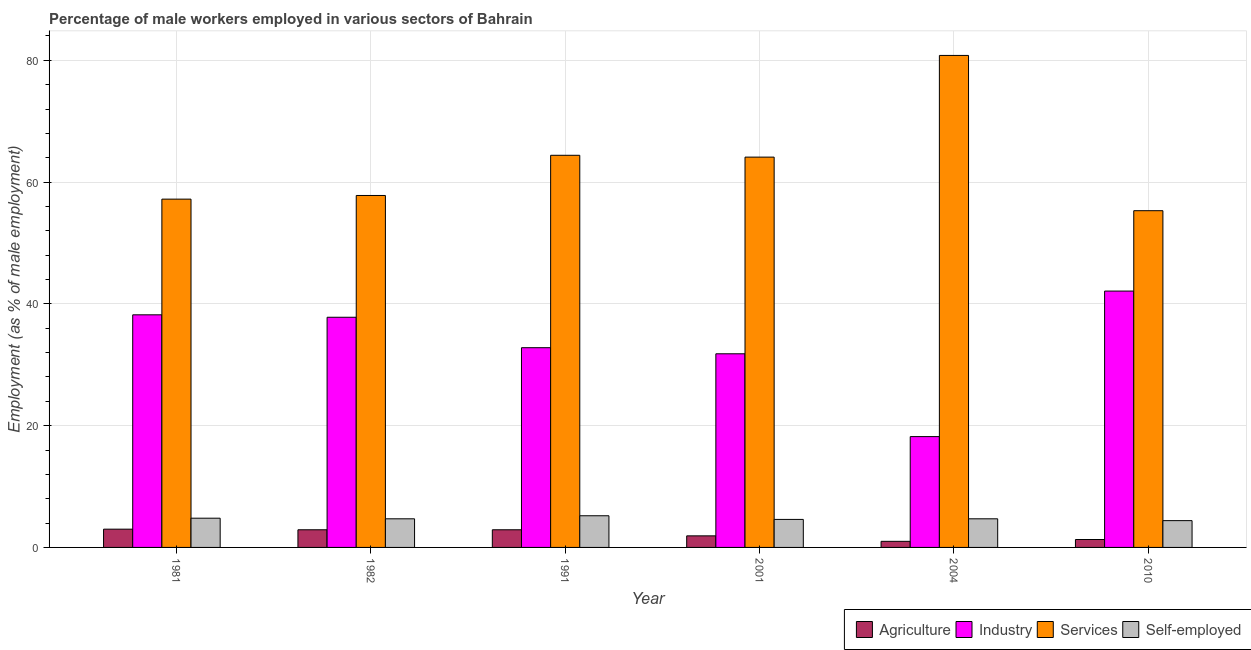How many different coloured bars are there?
Keep it short and to the point. 4. How many groups of bars are there?
Keep it short and to the point. 6. Are the number of bars on each tick of the X-axis equal?
Ensure brevity in your answer.  Yes. What is the percentage of male workers in industry in 1982?
Your answer should be very brief. 37.8. Across all years, what is the maximum percentage of male workers in industry?
Ensure brevity in your answer.  42.1. Across all years, what is the minimum percentage of male workers in services?
Your answer should be compact. 55.3. What is the total percentage of male workers in agriculture in the graph?
Your response must be concise. 13. What is the difference between the percentage of self employed male workers in 1981 and that in 2001?
Provide a succinct answer. 0.2. What is the difference between the percentage of male workers in industry in 1991 and the percentage of male workers in agriculture in 1982?
Your response must be concise. -5. What is the average percentage of male workers in agriculture per year?
Ensure brevity in your answer.  2.17. In the year 1991, what is the difference between the percentage of self employed male workers and percentage of male workers in agriculture?
Make the answer very short. 0. What is the ratio of the percentage of self employed male workers in 1991 to that in 2004?
Provide a succinct answer. 1.11. Is the percentage of male workers in services in 1981 less than that in 2001?
Provide a succinct answer. Yes. Is the difference between the percentage of male workers in agriculture in 1982 and 2001 greater than the difference between the percentage of self employed male workers in 1982 and 2001?
Your response must be concise. No. What is the difference between the highest and the second highest percentage of male workers in services?
Your answer should be compact. 16.4. What is the difference between the highest and the lowest percentage of self employed male workers?
Give a very brief answer. 0.8. In how many years, is the percentage of self employed male workers greater than the average percentage of self employed male workers taken over all years?
Keep it short and to the point. 2. Is the sum of the percentage of male workers in industry in 2004 and 2010 greater than the maximum percentage of male workers in services across all years?
Make the answer very short. Yes. Is it the case that in every year, the sum of the percentage of male workers in services and percentage of male workers in agriculture is greater than the sum of percentage of male workers in industry and percentage of self employed male workers?
Ensure brevity in your answer.  Yes. What does the 2nd bar from the left in 1981 represents?
Offer a very short reply. Industry. What does the 1st bar from the right in 2010 represents?
Provide a succinct answer. Self-employed. How many bars are there?
Make the answer very short. 24. Are all the bars in the graph horizontal?
Provide a succinct answer. No. How many years are there in the graph?
Offer a very short reply. 6. Does the graph contain any zero values?
Make the answer very short. No. Does the graph contain grids?
Provide a succinct answer. Yes. Where does the legend appear in the graph?
Your response must be concise. Bottom right. What is the title of the graph?
Your response must be concise. Percentage of male workers employed in various sectors of Bahrain. Does "Primary" appear as one of the legend labels in the graph?
Keep it short and to the point. No. What is the label or title of the Y-axis?
Give a very brief answer. Employment (as % of male employment). What is the Employment (as % of male employment) in Agriculture in 1981?
Your response must be concise. 3. What is the Employment (as % of male employment) in Industry in 1981?
Offer a terse response. 38.2. What is the Employment (as % of male employment) of Services in 1981?
Your answer should be very brief. 57.2. What is the Employment (as % of male employment) in Self-employed in 1981?
Provide a succinct answer. 4.8. What is the Employment (as % of male employment) of Agriculture in 1982?
Offer a terse response. 2.9. What is the Employment (as % of male employment) in Industry in 1982?
Provide a succinct answer. 37.8. What is the Employment (as % of male employment) in Services in 1982?
Ensure brevity in your answer.  57.8. What is the Employment (as % of male employment) of Self-employed in 1982?
Your answer should be compact. 4.7. What is the Employment (as % of male employment) of Agriculture in 1991?
Offer a terse response. 2.9. What is the Employment (as % of male employment) of Industry in 1991?
Ensure brevity in your answer.  32.8. What is the Employment (as % of male employment) in Services in 1991?
Your answer should be very brief. 64.4. What is the Employment (as % of male employment) of Self-employed in 1991?
Your answer should be very brief. 5.2. What is the Employment (as % of male employment) in Agriculture in 2001?
Offer a very short reply. 1.9. What is the Employment (as % of male employment) of Industry in 2001?
Keep it short and to the point. 31.8. What is the Employment (as % of male employment) of Services in 2001?
Your response must be concise. 64.1. What is the Employment (as % of male employment) of Self-employed in 2001?
Provide a succinct answer. 4.6. What is the Employment (as % of male employment) of Agriculture in 2004?
Give a very brief answer. 1. What is the Employment (as % of male employment) of Industry in 2004?
Offer a terse response. 18.2. What is the Employment (as % of male employment) of Services in 2004?
Offer a terse response. 80.8. What is the Employment (as % of male employment) in Self-employed in 2004?
Provide a succinct answer. 4.7. What is the Employment (as % of male employment) of Agriculture in 2010?
Make the answer very short. 1.3. What is the Employment (as % of male employment) of Industry in 2010?
Make the answer very short. 42.1. What is the Employment (as % of male employment) in Services in 2010?
Provide a short and direct response. 55.3. What is the Employment (as % of male employment) of Self-employed in 2010?
Your response must be concise. 4.4. Across all years, what is the maximum Employment (as % of male employment) of Agriculture?
Make the answer very short. 3. Across all years, what is the maximum Employment (as % of male employment) of Industry?
Keep it short and to the point. 42.1. Across all years, what is the maximum Employment (as % of male employment) of Services?
Offer a terse response. 80.8. Across all years, what is the maximum Employment (as % of male employment) in Self-employed?
Your answer should be compact. 5.2. Across all years, what is the minimum Employment (as % of male employment) of Industry?
Offer a terse response. 18.2. Across all years, what is the minimum Employment (as % of male employment) of Services?
Your answer should be very brief. 55.3. Across all years, what is the minimum Employment (as % of male employment) of Self-employed?
Your answer should be compact. 4.4. What is the total Employment (as % of male employment) in Agriculture in the graph?
Provide a short and direct response. 13. What is the total Employment (as % of male employment) of Industry in the graph?
Your answer should be very brief. 200.9. What is the total Employment (as % of male employment) of Services in the graph?
Make the answer very short. 379.6. What is the total Employment (as % of male employment) of Self-employed in the graph?
Provide a succinct answer. 28.4. What is the difference between the Employment (as % of male employment) of Agriculture in 1981 and that in 1982?
Your answer should be compact. 0.1. What is the difference between the Employment (as % of male employment) in Services in 1981 and that in 1982?
Your answer should be compact. -0.6. What is the difference between the Employment (as % of male employment) in Self-employed in 1981 and that in 1982?
Keep it short and to the point. 0.1. What is the difference between the Employment (as % of male employment) of Agriculture in 1981 and that in 2001?
Offer a terse response. 1.1. What is the difference between the Employment (as % of male employment) in Services in 1981 and that in 2001?
Your response must be concise. -6.9. What is the difference between the Employment (as % of male employment) in Self-employed in 1981 and that in 2001?
Keep it short and to the point. 0.2. What is the difference between the Employment (as % of male employment) of Agriculture in 1981 and that in 2004?
Your answer should be compact. 2. What is the difference between the Employment (as % of male employment) of Industry in 1981 and that in 2004?
Offer a very short reply. 20. What is the difference between the Employment (as % of male employment) in Services in 1981 and that in 2004?
Offer a terse response. -23.6. What is the difference between the Employment (as % of male employment) of Agriculture in 1981 and that in 2010?
Make the answer very short. 1.7. What is the difference between the Employment (as % of male employment) in Industry in 1982 and that in 1991?
Offer a very short reply. 5. What is the difference between the Employment (as % of male employment) in Self-employed in 1982 and that in 1991?
Provide a succinct answer. -0.5. What is the difference between the Employment (as % of male employment) of Agriculture in 1982 and that in 2001?
Your response must be concise. 1. What is the difference between the Employment (as % of male employment) of Industry in 1982 and that in 2001?
Make the answer very short. 6. What is the difference between the Employment (as % of male employment) of Services in 1982 and that in 2001?
Provide a short and direct response. -6.3. What is the difference between the Employment (as % of male employment) in Self-employed in 1982 and that in 2001?
Your response must be concise. 0.1. What is the difference between the Employment (as % of male employment) in Agriculture in 1982 and that in 2004?
Offer a terse response. 1.9. What is the difference between the Employment (as % of male employment) of Industry in 1982 and that in 2004?
Ensure brevity in your answer.  19.6. What is the difference between the Employment (as % of male employment) of Services in 1982 and that in 2004?
Your answer should be very brief. -23. What is the difference between the Employment (as % of male employment) of Self-employed in 1982 and that in 2004?
Ensure brevity in your answer.  0. What is the difference between the Employment (as % of male employment) of Industry in 1982 and that in 2010?
Give a very brief answer. -4.3. What is the difference between the Employment (as % of male employment) of Agriculture in 1991 and that in 2001?
Your response must be concise. 1. What is the difference between the Employment (as % of male employment) in Agriculture in 1991 and that in 2004?
Make the answer very short. 1.9. What is the difference between the Employment (as % of male employment) in Services in 1991 and that in 2004?
Ensure brevity in your answer.  -16.4. What is the difference between the Employment (as % of male employment) of Self-employed in 1991 and that in 2004?
Provide a succinct answer. 0.5. What is the difference between the Employment (as % of male employment) in Agriculture in 1991 and that in 2010?
Offer a terse response. 1.6. What is the difference between the Employment (as % of male employment) in Industry in 1991 and that in 2010?
Provide a succinct answer. -9.3. What is the difference between the Employment (as % of male employment) of Self-employed in 1991 and that in 2010?
Keep it short and to the point. 0.8. What is the difference between the Employment (as % of male employment) of Industry in 2001 and that in 2004?
Provide a short and direct response. 13.6. What is the difference between the Employment (as % of male employment) of Services in 2001 and that in 2004?
Provide a short and direct response. -16.7. What is the difference between the Employment (as % of male employment) of Agriculture in 2001 and that in 2010?
Make the answer very short. 0.6. What is the difference between the Employment (as % of male employment) of Industry in 2001 and that in 2010?
Your answer should be compact. -10.3. What is the difference between the Employment (as % of male employment) of Services in 2001 and that in 2010?
Give a very brief answer. 8.8. What is the difference between the Employment (as % of male employment) of Self-employed in 2001 and that in 2010?
Make the answer very short. 0.2. What is the difference between the Employment (as % of male employment) in Industry in 2004 and that in 2010?
Offer a very short reply. -23.9. What is the difference between the Employment (as % of male employment) in Self-employed in 2004 and that in 2010?
Offer a terse response. 0.3. What is the difference between the Employment (as % of male employment) of Agriculture in 1981 and the Employment (as % of male employment) of Industry in 1982?
Your answer should be compact. -34.8. What is the difference between the Employment (as % of male employment) in Agriculture in 1981 and the Employment (as % of male employment) in Services in 1982?
Ensure brevity in your answer.  -54.8. What is the difference between the Employment (as % of male employment) of Industry in 1981 and the Employment (as % of male employment) of Services in 1982?
Keep it short and to the point. -19.6. What is the difference between the Employment (as % of male employment) in Industry in 1981 and the Employment (as % of male employment) in Self-employed in 1982?
Your response must be concise. 33.5. What is the difference between the Employment (as % of male employment) in Services in 1981 and the Employment (as % of male employment) in Self-employed in 1982?
Offer a very short reply. 52.5. What is the difference between the Employment (as % of male employment) in Agriculture in 1981 and the Employment (as % of male employment) in Industry in 1991?
Provide a succinct answer. -29.8. What is the difference between the Employment (as % of male employment) in Agriculture in 1981 and the Employment (as % of male employment) in Services in 1991?
Offer a very short reply. -61.4. What is the difference between the Employment (as % of male employment) in Industry in 1981 and the Employment (as % of male employment) in Services in 1991?
Offer a terse response. -26.2. What is the difference between the Employment (as % of male employment) in Industry in 1981 and the Employment (as % of male employment) in Self-employed in 1991?
Keep it short and to the point. 33. What is the difference between the Employment (as % of male employment) of Services in 1981 and the Employment (as % of male employment) of Self-employed in 1991?
Give a very brief answer. 52. What is the difference between the Employment (as % of male employment) in Agriculture in 1981 and the Employment (as % of male employment) in Industry in 2001?
Your answer should be very brief. -28.8. What is the difference between the Employment (as % of male employment) of Agriculture in 1981 and the Employment (as % of male employment) of Services in 2001?
Provide a succinct answer. -61.1. What is the difference between the Employment (as % of male employment) of Industry in 1981 and the Employment (as % of male employment) of Services in 2001?
Your response must be concise. -25.9. What is the difference between the Employment (as % of male employment) of Industry in 1981 and the Employment (as % of male employment) of Self-employed in 2001?
Ensure brevity in your answer.  33.6. What is the difference between the Employment (as % of male employment) of Services in 1981 and the Employment (as % of male employment) of Self-employed in 2001?
Your response must be concise. 52.6. What is the difference between the Employment (as % of male employment) of Agriculture in 1981 and the Employment (as % of male employment) of Industry in 2004?
Offer a very short reply. -15.2. What is the difference between the Employment (as % of male employment) in Agriculture in 1981 and the Employment (as % of male employment) in Services in 2004?
Your answer should be compact. -77.8. What is the difference between the Employment (as % of male employment) in Industry in 1981 and the Employment (as % of male employment) in Services in 2004?
Provide a short and direct response. -42.6. What is the difference between the Employment (as % of male employment) in Industry in 1981 and the Employment (as % of male employment) in Self-employed in 2004?
Your response must be concise. 33.5. What is the difference between the Employment (as % of male employment) in Services in 1981 and the Employment (as % of male employment) in Self-employed in 2004?
Your response must be concise. 52.5. What is the difference between the Employment (as % of male employment) in Agriculture in 1981 and the Employment (as % of male employment) in Industry in 2010?
Keep it short and to the point. -39.1. What is the difference between the Employment (as % of male employment) in Agriculture in 1981 and the Employment (as % of male employment) in Services in 2010?
Provide a short and direct response. -52.3. What is the difference between the Employment (as % of male employment) in Agriculture in 1981 and the Employment (as % of male employment) in Self-employed in 2010?
Offer a very short reply. -1.4. What is the difference between the Employment (as % of male employment) of Industry in 1981 and the Employment (as % of male employment) of Services in 2010?
Provide a succinct answer. -17.1. What is the difference between the Employment (as % of male employment) in Industry in 1981 and the Employment (as % of male employment) in Self-employed in 2010?
Your response must be concise. 33.8. What is the difference between the Employment (as % of male employment) of Services in 1981 and the Employment (as % of male employment) of Self-employed in 2010?
Give a very brief answer. 52.8. What is the difference between the Employment (as % of male employment) in Agriculture in 1982 and the Employment (as % of male employment) in Industry in 1991?
Make the answer very short. -29.9. What is the difference between the Employment (as % of male employment) of Agriculture in 1982 and the Employment (as % of male employment) of Services in 1991?
Your answer should be compact. -61.5. What is the difference between the Employment (as % of male employment) in Agriculture in 1982 and the Employment (as % of male employment) in Self-employed in 1991?
Make the answer very short. -2.3. What is the difference between the Employment (as % of male employment) in Industry in 1982 and the Employment (as % of male employment) in Services in 1991?
Offer a very short reply. -26.6. What is the difference between the Employment (as % of male employment) in Industry in 1982 and the Employment (as % of male employment) in Self-employed in 1991?
Make the answer very short. 32.6. What is the difference between the Employment (as % of male employment) in Services in 1982 and the Employment (as % of male employment) in Self-employed in 1991?
Keep it short and to the point. 52.6. What is the difference between the Employment (as % of male employment) in Agriculture in 1982 and the Employment (as % of male employment) in Industry in 2001?
Give a very brief answer. -28.9. What is the difference between the Employment (as % of male employment) in Agriculture in 1982 and the Employment (as % of male employment) in Services in 2001?
Provide a short and direct response. -61.2. What is the difference between the Employment (as % of male employment) in Agriculture in 1982 and the Employment (as % of male employment) in Self-employed in 2001?
Ensure brevity in your answer.  -1.7. What is the difference between the Employment (as % of male employment) of Industry in 1982 and the Employment (as % of male employment) of Services in 2001?
Make the answer very short. -26.3. What is the difference between the Employment (as % of male employment) in Industry in 1982 and the Employment (as % of male employment) in Self-employed in 2001?
Make the answer very short. 33.2. What is the difference between the Employment (as % of male employment) of Services in 1982 and the Employment (as % of male employment) of Self-employed in 2001?
Offer a very short reply. 53.2. What is the difference between the Employment (as % of male employment) in Agriculture in 1982 and the Employment (as % of male employment) in Industry in 2004?
Offer a terse response. -15.3. What is the difference between the Employment (as % of male employment) of Agriculture in 1982 and the Employment (as % of male employment) of Services in 2004?
Your response must be concise. -77.9. What is the difference between the Employment (as % of male employment) of Agriculture in 1982 and the Employment (as % of male employment) of Self-employed in 2004?
Offer a terse response. -1.8. What is the difference between the Employment (as % of male employment) of Industry in 1982 and the Employment (as % of male employment) of Services in 2004?
Make the answer very short. -43. What is the difference between the Employment (as % of male employment) in Industry in 1982 and the Employment (as % of male employment) in Self-employed in 2004?
Offer a terse response. 33.1. What is the difference between the Employment (as % of male employment) in Services in 1982 and the Employment (as % of male employment) in Self-employed in 2004?
Your answer should be compact. 53.1. What is the difference between the Employment (as % of male employment) in Agriculture in 1982 and the Employment (as % of male employment) in Industry in 2010?
Your response must be concise. -39.2. What is the difference between the Employment (as % of male employment) of Agriculture in 1982 and the Employment (as % of male employment) of Services in 2010?
Make the answer very short. -52.4. What is the difference between the Employment (as % of male employment) of Industry in 1982 and the Employment (as % of male employment) of Services in 2010?
Provide a short and direct response. -17.5. What is the difference between the Employment (as % of male employment) in Industry in 1982 and the Employment (as % of male employment) in Self-employed in 2010?
Ensure brevity in your answer.  33.4. What is the difference between the Employment (as % of male employment) in Services in 1982 and the Employment (as % of male employment) in Self-employed in 2010?
Keep it short and to the point. 53.4. What is the difference between the Employment (as % of male employment) in Agriculture in 1991 and the Employment (as % of male employment) in Industry in 2001?
Your answer should be compact. -28.9. What is the difference between the Employment (as % of male employment) of Agriculture in 1991 and the Employment (as % of male employment) of Services in 2001?
Keep it short and to the point. -61.2. What is the difference between the Employment (as % of male employment) of Agriculture in 1991 and the Employment (as % of male employment) of Self-employed in 2001?
Offer a terse response. -1.7. What is the difference between the Employment (as % of male employment) of Industry in 1991 and the Employment (as % of male employment) of Services in 2001?
Your answer should be very brief. -31.3. What is the difference between the Employment (as % of male employment) of Industry in 1991 and the Employment (as % of male employment) of Self-employed in 2001?
Keep it short and to the point. 28.2. What is the difference between the Employment (as % of male employment) in Services in 1991 and the Employment (as % of male employment) in Self-employed in 2001?
Make the answer very short. 59.8. What is the difference between the Employment (as % of male employment) of Agriculture in 1991 and the Employment (as % of male employment) of Industry in 2004?
Give a very brief answer. -15.3. What is the difference between the Employment (as % of male employment) in Agriculture in 1991 and the Employment (as % of male employment) in Services in 2004?
Give a very brief answer. -77.9. What is the difference between the Employment (as % of male employment) in Agriculture in 1991 and the Employment (as % of male employment) in Self-employed in 2004?
Your response must be concise. -1.8. What is the difference between the Employment (as % of male employment) in Industry in 1991 and the Employment (as % of male employment) in Services in 2004?
Provide a succinct answer. -48. What is the difference between the Employment (as % of male employment) in Industry in 1991 and the Employment (as % of male employment) in Self-employed in 2004?
Make the answer very short. 28.1. What is the difference between the Employment (as % of male employment) in Services in 1991 and the Employment (as % of male employment) in Self-employed in 2004?
Offer a very short reply. 59.7. What is the difference between the Employment (as % of male employment) of Agriculture in 1991 and the Employment (as % of male employment) of Industry in 2010?
Your response must be concise. -39.2. What is the difference between the Employment (as % of male employment) of Agriculture in 1991 and the Employment (as % of male employment) of Services in 2010?
Offer a terse response. -52.4. What is the difference between the Employment (as % of male employment) in Industry in 1991 and the Employment (as % of male employment) in Services in 2010?
Your answer should be compact. -22.5. What is the difference between the Employment (as % of male employment) in Industry in 1991 and the Employment (as % of male employment) in Self-employed in 2010?
Keep it short and to the point. 28.4. What is the difference between the Employment (as % of male employment) of Agriculture in 2001 and the Employment (as % of male employment) of Industry in 2004?
Keep it short and to the point. -16.3. What is the difference between the Employment (as % of male employment) in Agriculture in 2001 and the Employment (as % of male employment) in Services in 2004?
Make the answer very short. -78.9. What is the difference between the Employment (as % of male employment) of Industry in 2001 and the Employment (as % of male employment) of Services in 2004?
Keep it short and to the point. -49. What is the difference between the Employment (as % of male employment) of Industry in 2001 and the Employment (as % of male employment) of Self-employed in 2004?
Provide a succinct answer. 27.1. What is the difference between the Employment (as % of male employment) in Services in 2001 and the Employment (as % of male employment) in Self-employed in 2004?
Your response must be concise. 59.4. What is the difference between the Employment (as % of male employment) in Agriculture in 2001 and the Employment (as % of male employment) in Industry in 2010?
Your answer should be very brief. -40.2. What is the difference between the Employment (as % of male employment) of Agriculture in 2001 and the Employment (as % of male employment) of Services in 2010?
Your response must be concise. -53.4. What is the difference between the Employment (as % of male employment) in Agriculture in 2001 and the Employment (as % of male employment) in Self-employed in 2010?
Your response must be concise. -2.5. What is the difference between the Employment (as % of male employment) in Industry in 2001 and the Employment (as % of male employment) in Services in 2010?
Offer a terse response. -23.5. What is the difference between the Employment (as % of male employment) in Industry in 2001 and the Employment (as % of male employment) in Self-employed in 2010?
Your response must be concise. 27.4. What is the difference between the Employment (as % of male employment) of Services in 2001 and the Employment (as % of male employment) of Self-employed in 2010?
Your answer should be compact. 59.7. What is the difference between the Employment (as % of male employment) in Agriculture in 2004 and the Employment (as % of male employment) in Industry in 2010?
Offer a very short reply. -41.1. What is the difference between the Employment (as % of male employment) in Agriculture in 2004 and the Employment (as % of male employment) in Services in 2010?
Keep it short and to the point. -54.3. What is the difference between the Employment (as % of male employment) in Industry in 2004 and the Employment (as % of male employment) in Services in 2010?
Ensure brevity in your answer.  -37.1. What is the difference between the Employment (as % of male employment) in Services in 2004 and the Employment (as % of male employment) in Self-employed in 2010?
Your response must be concise. 76.4. What is the average Employment (as % of male employment) in Agriculture per year?
Your answer should be compact. 2.17. What is the average Employment (as % of male employment) of Industry per year?
Your response must be concise. 33.48. What is the average Employment (as % of male employment) in Services per year?
Your answer should be compact. 63.27. What is the average Employment (as % of male employment) in Self-employed per year?
Your answer should be very brief. 4.73. In the year 1981, what is the difference between the Employment (as % of male employment) in Agriculture and Employment (as % of male employment) in Industry?
Ensure brevity in your answer.  -35.2. In the year 1981, what is the difference between the Employment (as % of male employment) in Agriculture and Employment (as % of male employment) in Services?
Provide a short and direct response. -54.2. In the year 1981, what is the difference between the Employment (as % of male employment) in Agriculture and Employment (as % of male employment) in Self-employed?
Keep it short and to the point. -1.8. In the year 1981, what is the difference between the Employment (as % of male employment) of Industry and Employment (as % of male employment) of Services?
Offer a very short reply. -19. In the year 1981, what is the difference between the Employment (as % of male employment) in Industry and Employment (as % of male employment) in Self-employed?
Ensure brevity in your answer.  33.4. In the year 1981, what is the difference between the Employment (as % of male employment) of Services and Employment (as % of male employment) of Self-employed?
Make the answer very short. 52.4. In the year 1982, what is the difference between the Employment (as % of male employment) in Agriculture and Employment (as % of male employment) in Industry?
Your response must be concise. -34.9. In the year 1982, what is the difference between the Employment (as % of male employment) in Agriculture and Employment (as % of male employment) in Services?
Ensure brevity in your answer.  -54.9. In the year 1982, what is the difference between the Employment (as % of male employment) of Agriculture and Employment (as % of male employment) of Self-employed?
Ensure brevity in your answer.  -1.8. In the year 1982, what is the difference between the Employment (as % of male employment) in Industry and Employment (as % of male employment) in Self-employed?
Make the answer very short. 33.1. In the year 1982, what is the difference between the Employment (as % of male employment) of Services and Employment (as % of male employment) of Self-employed?
Your answer should be compact. 53.1. In the year 1991, what is the difference between the Employment (as % of male employment) of Agriculture and Employment (as % of male employment) of Industry?
Your answer should be compact. -29.9. In the year 1991, what is the difference between the Employment (as % of male employment) of Agriculture and Employment (as % of male employment) of Services?
Make the answer very short. -61.5. In the year 1991, what is the difference between the Employment (as % of male employment) in Agriculture and Employment (as % of male employment) in Self-employed?
Offer a very short reply. -2.3. In the year 1991, what is the difference between the Employment (as % of male employment) of Industry and Employment (as % of male employment) of Services?
Provide a short and direct response. -31.6. In the year 1991, what is the difference between the Employment (as % of male employment) in Industry and Employment (as % of male employment) in Self-employed?
Give a very brief answer. 27.6. In the year 1991, what is the difference between the Employment (as % of male employment) of Services and Employment (as % of male employment) of Self-employed?
Provide a succinct answer. 59.2. In the year 2001, what is the difference between the Employment (as % of male employment) of Agriculture and Employment (as % of male employment) of Industry?
Offer a very short reply. -29.9. In the year 2001, what is the difference between the Employment (as % of male employment) in Agriculture and Employment (as % of male employment) in Services?
Ensure brevity in your answer.  -62.2. In the year 2001, what is the difference between the Employment (as % of male employment) in Agriculture and Employment (as % of male employment) in Self-employed?
Give a very brief answer. -2.7. In the year 2001, what is the difference between the Employment (as % of male employment) in Industry and Employment (as % of male employment) in Services?
Give a very brief answer. -32.3. In the year 2001, what is the difference between the Employment (as % of male employment) of Industry and Employment (as % of male employment) of Self-employed?
Make the answer very short. 27.2. In the year 2001, what is the difference between the Employment (as % of male employment) in Services and Employment (as % of male employment) in Self-employed?
Provide a succinct answer. 59.5. In the year 2004, what is the difference between the Employment (as % of male employment) of Agriculture and Employment (as % of male employment) of Industry?
Provide a succinct answer. -17.2. In the year 2004, what is the difference between the Employment (as % of male employment) in Agriculture and Employment (as % of male employment) in Services?
Make the answer very short. -79.8. In the year 2004, what is the difference between the Employment (as % of male employment) of Agriculture and Employment (as % of male employment) of Self-employed?
Your answer should be very brief. -3.7. In the year 2004, what is the difference between the Employment (as % of male employment) of Industry and Employment (as % of male employment) of Services?
Ensure brevity in your answer.  -62.6. In the year 2004, what is the difference between the Employment (as % of male employment) of Industry and Employment (as % of male employment) of Self-employed?
Offer a terse response. 13.5. In the year 2004, what is the difference between the Employment (as % of male employment) of Services and Employment (as % of male employment) of Self-employed?
Keep it short and to the point. 76.1. In the year 2010, what is the difference between the Employment (as % of male employment) in Agriculture and Employment (as % of male employment) in Industry?
Your response must be concise. -40.8. In the year 2010, what is the difference between the Employment (as % of male employment) of Agriculture and Employment (as % of male employment) of Services?
Keep it short and to the point. -54. In the year 2010, what is the difference between the Employment (as % of male employment) of Industry and Employment (as % of male employment) of Services?
Make the answer very short. -13.2. In the year 2010, what is the difference between the Employment (as % of male employment) in Industry and Employment (as % of male employment) in Self-employed?
Make the answer very short. 37.7. In the year 2010, what is the difference between the Employment (as % of male employment) in Services and Employment (as % of male employment) in Self-employed?
Give a very brief answer. 50.9. What is the ratio of the Employment (as % of male employment) of Agriculture in 1981 to that in 1982?
Your answer should be compact. 1.03. What is the ratio of the Employment (as % of male employment) of Industry in 1981 to that in 1982?
Offer a terse response. 1.01. What is the ratio of the Employment (as % of male employment) in Services in 1981 to that in 1982?
Your answer should be very brief. 0.99. What is the ratio of the Employment (as % of male employment) of Self-employed in 1981 to that in 1982?
Offer a terse response. 1.02. What is the ratio of the Employment (as % of male employment) in Agriculture in 1981 to that in 1991?
Keep it short and to the point. 1.03. What is the ratio of the Employment (as % of male employment) in Industry in 1981 to that in 1991?
Your response must be concise. 1.16. What is the ratio of the Employment (as % of male employment) of Services in 1981 to that in 1991?
Ensure brevity in your answer.  0.89. What is the ratio of the Employment (as % of male employment) in Agriculture in 1981 to that in 2001?
Offer a terse response. 1.58. What is the ratio of the Employment (as % of male employment) in Industry in 1981 to that in 2001?
Provide a short and direct response. 1.2. What is the ratio of the Employment (as % of male employment) in Services in 1981 to that in 2001?
Offer a very short reply. 0.89. What is the ratio of the Employment (as % of male employment) in Self-employed in 1981 to that in 2001?
Your response must be concise. 1.04. What is the ratio of the Employment (as % of male employment) in Industry in 1981 to that in 2004?
Offer a very short reply. 2.1. What is the ratio of the Employment (as % of male employment) in Services in 1981 to that in 2004?
Give a very brief answer. 0.71. What is the ratio of the Employment (as % of male employment) of Self-employed in 1981 to that in 2004?
Offer a very short reply. 1.02. What is the ratio of the Employment (as % of male employment) of Agriculture in 1981 to that in 2010?
Your response must be concise. 2.31. What is the ratio of the Employment (as % of male employment) of Industry in 1981 to that in 2010?
Offer a very short reply. 0.91. What is the ratio of the Employment (as % of male employment) in Services in 1981 to that in 2010?
Your response must be concise. 1.03. What is the ratio of the Employment (as % of male employment) of Agriculture in 1982 to that in 1991?
Provide a short and direct response. 1. What is the ratio of the Employment (as % of male employment) of Industry in 1982 to that in 1991?
Provide a short and direct response. 1.15. What is the ratio of the Employment (as % of male employment) in Services in 1982 to that in 1991?
Your response must be concise. 0.9. What is the ratio of the Employment (as % of male employment) in Self-employed in 1982 to that in 1991?
Your response must be concise. 0.9. What is the ratio of the Employment (as % of male employment) in Agriculture in 1982 to that in 2001?
Your response must be concise. 1.53. What is the ratio of the Employment (as % of male employment) of Industry in 1982 to that in 2001?
Provide a short and direct response. 1.19. What is the ratio of the Employment (as % of male employment) in Services in 1982 to that in 2001?
Your response must be concise. 0.9. What is the ratio of the Employment (as % of male employment) of Self-employed in 1982 to that in 2001?
Give a very brief answer. 1.02. What is the ratio of the Employment (as % of male employment) of Industry in 1982 to that in 2004?
Give a very brief answer. 2.08. What is the ratio of the Employment (as % of male employment) of Services in 1982 to that in 2004?
Your answer should be very brief. 0.72. What is the ratio of the Employment (as % of male employment) of Self-employed in 1982 to that in 2004?
Your answer should be very brief. 1. What is the ratio of the Employment (as % of male employment) in Agriculture in 1982 to that in 2010?
Your response must be concise. 2.23. What is the ratio of the Employment (as % of male employment) of Industry in 1982 to that in 2010?
Offer a very short reply. 0.9. What is the ratio of the Employment (as % of male employment) of Services in 1982 to that in 2010?
Make the answer very short. 1.05. What is the ratio of the Employment (as % of male employment) of Self-employed in 1982 to that in 2010?
Offer a very short reply. 1.07. What is the ratio of the Employment (as % of male employment) of Agriculture in 1991 to that in 2001?
Ensure brevity in your answer.  1.53. What is the ratio of the Employment (as % of male employment) in Industry in 1991 to that in 2001?
Make the answer very short. 1.03. What is the ratio of the Employment (as % of male employment) in Self-employed in 1991 to that in 2001?
Your response must be concise. 1.13. What is the ratio of the Employment (as % of male employment) in Agriculture in 1991 to that in 2004?
Keep it short and to the point. 2.9. What is the ratio of the Employment (as % of male employment) in Industry in 1991 to that in 2004?
Provide a succinct answer. 1.8. What is the ratio of the Employment (as % of male employment) in Services in 1991 to that in 2004?
Offer a terse response. 0.8. What is the ratio of the Employment (as % of male employment) of Self-employed in 1991 to that in 2004?
Give a very brief answer. 1.11. What is the ratio of the Employment (as % of male employment) in Agriculture in 1991 to that in 2010?
Give a very brief answer. 2.23. What is the ratio of the Employment (as % of male employment) of Industry in 1991 to that in 2010?
Keep it short and to the point. 0.78. What is the ratio of the Employment (as % of male employment) in Services in 1991 to that in 2010?
Keep it short and to the point. 1.16. What is the ratio of the Employment (as % of male employment) of Self-employed in 1991 to that in 2010?
Offer a terse response. 1.18. What is the ratio of the Employment (as % of male employment) of Agriculture in 2001 to that in 2004?
Your answer should be very brief. 1.9. What is the ratio of the Employment (as % of male employment) in Industry in 2001 to that in 2004?
Your response must be concise. 1.75. What is the ratio of the Employment (as % of male employment) of Services in 2001 to that in 2004?
Provide a succinct answer. 0.79. What is the ratio of the Employment (as % of male employment) of Self-employed in 2001 to that in 2004?
Provide a succinct answer. 0.98. What is the ratio of the Employment (as % of male employment) of Agriculture in 2001 to that in 2010?
Make the answer very short. 1.46. What is the ratio of the Employment (as % of male employment) of Industry in 2001 to that in 2010?
Give a very brief answer. 0.76. What is the ratio of the Employment (as % of male employment) of Services in 2001 to that in 2010?
Make the answer very short. 1.16. What is the ratio of the Employment (as % of male employment) in Self-employed in 2001 to that in 2010?
Ensure brevity in your answer.  1.05. What is the ratio of the Employment (as % of male employment) in Agriculture in 2004 to that in 2010?
Your response must be concise. 0.77. What is the ratio of the Employment (as % of male employment) in Industry in 2004 to that in 2010?
Offer a terse response. 0.43. What is the ratio of the Employment (as % of male employment) in Services in 2004 to that in 2010?
Keep it short and to the point. 1.46. What is the ratio of the Employment (as % of male employment) in Self-employed in 2004 to that in 2010?
Offer a very short reply. 1.07. What is the difference between the highest and the second highest Employment (as % of male employment) in Industry?
Your answer should be very brief. 3.9. What is the difference between the highest and the second highest Employment (as % of male employment) in Services?
Your response must be concise. 16.4. What is the difference between the highest and the second highest Employment (as % of male employment) of Self-employed?
Ensure brevity in your answer.  0.4. What is the difference between the highest and the lowest Employment (as % of male employment) in Agriculture?
Your answer should be very brief. 2. What is the difference between the highest and the lowest Employment (as % of male employment) of Industry?
Offer a very short reply. 23.9. What is the difference between the highest and the lowest Employment (as % of male employment) of Self-employed?
Give a very brief answer. 0.8. 